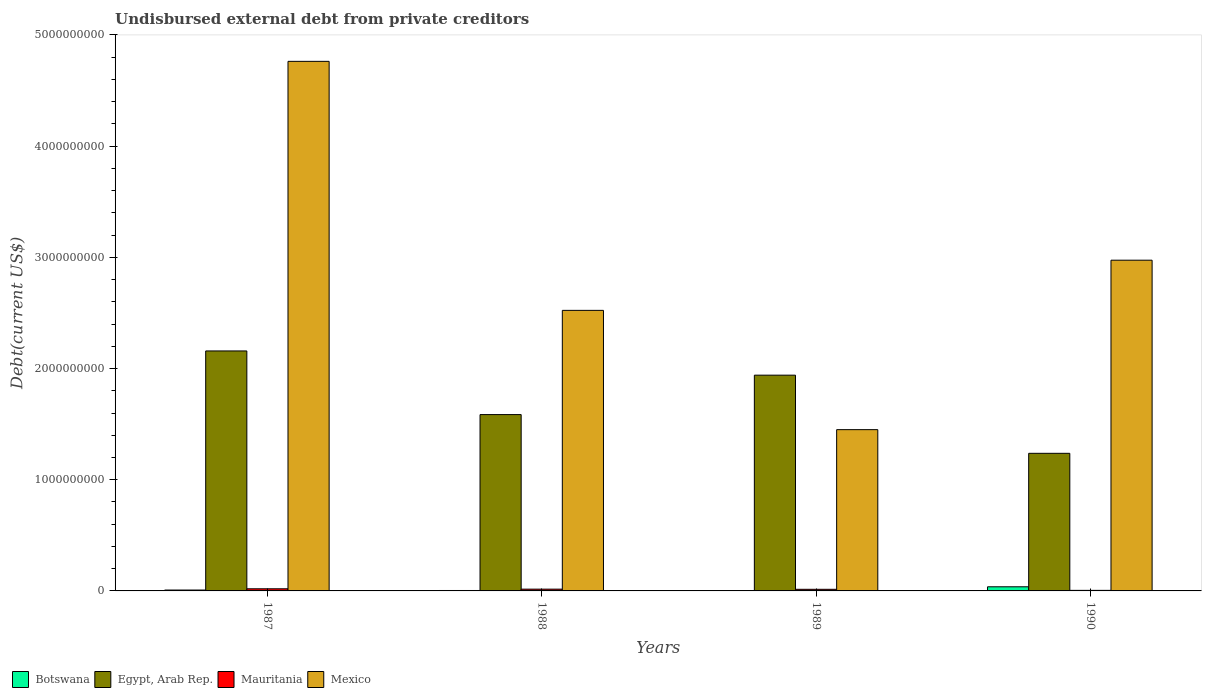How many different coloured bars are there?
Your answer should be very brief. 4. Are the number of bars per tick equal to the number of legend labels?
Your answer should be very brief. Yes. How many bars are there on the 4th tick from the left?
Your answer should be very brief. 4. How many bars are there on the 2nd tick from the right?
Your answer should be compact. 4. What is the label of the 1st group of bars from the left?
Offer a very short reply. 1987. In how many cases, is the number of bars for a given year not equal to the number of legend labels?
Provide a short and direct response. 0. What is the total debt in Mauritania in 1989?
Your response must be concise. 1.46e+07. Across all years, what is the maximum total debt in Mauritania?
Provide a short and direct response. 1.92e+07. Across all years, what is the minimum total debt in Egypt, Arab Rep.?
Provide a succinct answer. 1.24e+09. In which year was the total debt in Mauritania maximum?
Your answer should be compact. 1987. What is the total total debt in Mauritania in the graph?
Offer a terse response. 5.47e+07. What is the difference between the total debt in Botswana in 1988 and that in 1989?
Provide a short and direct response. 6.15e+05. What is the difference between the total debt in Mexico in 1987 and the total debt in Botswana in 1989?
Ensure brevity in your answer.  4.76e+09. What is the average total debt in Mexico per year?
Ensure brevity in your answer.  2.93e+09. In the year 1988, what is the difference between the total debt in Botswana and total debt in Mauritania?
Provide a short and direct response. -1.20e+07. What is the ratio of the total debt in Botswana in 1988 to that in 1990?
Offer a very short reply. 0.1. What is the difference between the highest and the second highest total debt in Mexico?
Make the answer very short. 1.79e+09. What is the difference between the highest and the lowest total debt in Botswana?
Provide a short and direct response. 3.39e+07. In how many years, is the total debt in Mauritania greater than the average total debt in Mauritania taken over all years?
Keep it short and to the point. 3. Is the sum of the total debt in Egypt, Arab Rep. in 1989 and 1990 greater than the maximum total debt in Mexico across all years?
Make the answer very short. No. Is it the case that in every year, the sum of the total debt in Mauritania and total debt in Mexico is greater than the sum of total debt in Botswana and total debt in Egypt, Arab Rep.?
Your response must be concise. Yes. What does the 3rd bar from the left in 1987 represents?
Your answer should be very brief. Mauritania. What does the 4th bar from the right in 1988 represents?
Keep it short and to the point. Botswana. Is it the case that in every year, the sum of the total debt in Botswana and total debt in Mexico is greater than the total debt in Egypt, Arab Rep.?
Offer a very short reply. No. Are all the bars in the graph horizontal?
Provide a short and direct response. No. Does the graph contain any zero values?
Your response must be concise. No. Does the graph contain grids?
Your answer should be compact. No. Where does the legend appear in the graph?
Your response must be concise. Bottom left. What is the title of the graph?
Your answer should be compact. Undisbursed external debt from private creditors. What is the label or title of the Y-axis?
Your answer should be compact. Debt(current US$). What is the Debt(current US$) in Botswana in 1987?
Make the answer very short. 7.99e+06. What is the Debt(current US$) of Egypt, Arab Rep. in 1987?
Give a very brief answer. 2.16e+09. What is the Debt(current US$) of Mauritania in 1987?
Offer a very short reply. 1.92e+07. What is the Debt(current US$) of Mexico in 1987?
Offer a very short reply. 4.76e+09. What is the Debt(current US$) in Botswana in 1988?
Provide a succinct answer. 3.90e+06. What is the Debt(current US$) in Egypt, Arab Rep. in 1988?
Provide a short and direct response. 1.59e+09. What is the Debt(current US$) of Mauritania in 1988?
Ensure brevity in your answer.  1.59e+07. What is the Debt(current US$) in Mexico in 1988?
Your response must be concise. 2.52e+09. What is the Debt(current US$) in Botswana in 1989?
Offer a terse response. 3.28e+06. What is the Debt(current US$) in Egypt, Arab Rep. in 1989?
Ensure brevity in your answer.  1.94e+09. What is the Debt(current US$) of Mauritania in 1989?
Ensure brevity in your answer.  1.46e+07. What is the Debt(current US$) of Mexico in 1989?
Ensure brevity in your answer.  1.45e+09. What is the Debt(current US$) of Botswana in 1990?
Provide a short and direct response. 3.72e+07. What is the Debt(current US$) in Egypt, Arab Rep. in 1990?
Make the answer very short. 1.24e+09. What is the Debt(current US$) of Mauritania in 1990?
Make the answer very short. 4.95e+06. What is the Debt(current US$) of Mexico in 1990?
Provide a succinct answer. 2.97e+09. Across all years, what is the maximum Debt(current US$) in Botswana?
Provide a succinct answer. 3.72e+07. Across all years, what is the maximum Debt(current US$) in Egypt, Arab Rep.?
Your response must be concise. 2.16e+09. Across all years, what is the maximum Debt(current US$) of Mauritania?
Provide a short and direct response. 1.92e+07. Across all years, what is the maximum Debt(current US$) in Mexico?
Your answer should be very brief. 4.76e+09. Across all years, what is the minimum Debt(current US$) of Botswana?
Your answer should be compact. 3.28e+06. Across all years, what is the minimum Debt(current US$) in Egypt, Arab Rep.?
Your answer should be very brief. 1.24e+09. Across all years, what is the minimum Debt(current US$) of Mauritania?
Give a very brief answer. 4.95e+06. Across all years, what is the minimum Debt(current US$) in Mexico?
Your answer should be compact. 1.45e+09. What is the total Debt(current US$) of Botswana in the graph?
Provide a succinct answer. 5.23e+07. What is the total Debt(current US$) in Egypt, Arab Rep. in the graph?
Keep it short and to the point. 6.92e+09. What is the total Debt(current US$) in Mauritania in the graph?
Offer a terse response. 5.47e+07. What is the total Debt(current US$) of Mexico in the graph?
Keep it short and to the point. 1.17e+1. What is the difference between the Debt(current US$) of Botswana in 1987 and that in 1988?
Give a very brief answer. 4.09e+06. What is the difference between the Debt(current US$) of Egypt, Arab Rep. in 1987 and that in 1988?
Make the answer very short. 5.72e+08. What is the difference between the Debt(current US$) of Mauritania in 1987 and that in 1988?
Give a very brief answer. 3.28e+06. What is the difference between the Debt(current US$) in Mexico in 1987 and that in 1988?
Offer a very short reply. 2.24e+09. What is the difference between the Debt(current US$) in Botswana in 1987 and that in 1989?
Provide a short and direct response. 4.70e+06. What is the difference between the Debt(current US$) in Egypt, Arab Rep. in 1987 and that in 1989?
Make the answer very short. 2.18e+08. What is the difference between the Debt(current US$) in Mauritania in 1987 and that in 1989?
Ensure brevity in your answer.  4.65e+06. What is the difference between the Debt(current US$) in Mexico in 1987 and that in 1989?
Your response must be concise. 3.31e+09. What is the difference between the Debt(current US$) in Botswana in 1987 and that in 1990?
Provide a short and direct response. -2.92e+07. What is the difference between the Debt(current US$) of Egypt, Arab Rep. in 1987 and that in 1990?
Provide a short and direct response. 9.21e+08. What is the difference between the Debt(current US$) in Mauritania in 1987 and that in 1990?
Provide a short and direct response. 1.43e+07. What is the difference between the Debt(current US$) of Mexico in 1987 and that in 1990?
Keep it short and to the point. 1.79e+09. What is the difference between the Debt(current US$) in Botswana in 1988 and that in 1989?
Give a very brief answer. 6.15e+05. What is the difference between the Debt(current US$) of Egypt, Arab Rep. in 1988 and that in 1989?
Ensure brevity in your answer.  -3.54e+08. What is the difference between the Debt(current US$) in Mauritania in 1988 and that in 1989?
Make the answer very short. 1.37e+06. What is the difference between the Debt(current US$) in Mexico in 1988 and that in 1989?
Make the answer very short. 1.07e+09. What is the difference between the Debt(current US$) in Botswana in 1988 and that in 1990?
Ensure brevity in your answer.  -3.33e+07. What is the difference between the Debt(current US$) of Egypt, Arab Rep. in 1988 and that in 1990?
Ensure brevity in your answer.  3.48e+08. What is the difference between the Debt(current US$) in Mauritania in 1988 and that in 1990?
Make the answer very short. 1.10e+07. What is the difference between the Debt(current US$) of Mexico in 1988 and that in 1990?
Offer a very short reply. -4.51e+08. What is the difference between the Debt(current US$) of Botswana in 1989 and that in 1990?
Your response must be concise. -3.39e+07. What is the difference between the Debt(current US$) in Egypt, Arab Rep. in 1989 and that in 1990?
Offer a terse response. 7.03e+08. What is the difference between the Debt(current US$) in Mauritania in 1989 and that in 1990?
Offer a terse response. 9.63e+06. What is the difference between the Debt(current US$) in Mexico in 1989 and that in 1990?
Offer a very short reply. -1.52e+09. What is the difference between the Debt(current US$) of Botswana in 1987 and the Debt(current US$) of Egypt, Arab Rep. in 1988?
Provide a short and direct response. -1.58e+09. What is the difference between the Debt(current US$) of Botswana in 1987 and the Debt(current US$) of Mauritania in 1988?
Keep it short and to the point. -7.96e+06. What is the difference between the Debt(current US$) in Botswana in 1987 and the Debt(current US$) in Mexico in 1988?
Your answer should be compact. -2.51e+09. What is the difference between the Debt(current US$) in Egypt, Arab Rep. in 1987 and the Debt(current US$) in Mauritania in 1988?
Provide a succinct answer. 2.14e+09. What is the difference between the Debt(current US$) of Egypt, Arab Rep. in 1987 and the Debt(current US$) of Mexico in 1988?
Make the answer very short. -3.65e+08. What is the difference between the Debt(current US$) in Mauritania in 1987 and the Debt(current US$) in Mexico in 1988?
Keep it short and to the point. -2.50e+09. What is the difference between the Debt(current US$) of Botswana in 1987 and the Debt(current US$) of Egypt, Arab Rep. in 1989?
Your answer should be compact. -1.93e+09. What is the difference between the Debt(current US$) in Botswana in 1987 and the Debt(current US$) in Mauritania in 1989?
Offer a very short reply. -6.60e+06. What is the difference between the Debt(current US$) in Botswana in 1987 and the Debt(current US$) in Mexico in 1989?
Ensure brevity in your answer.  -1.44e+09. What is the difference between the Debt(current US$) in Egypt, Arab Rep. in 1987 and the Debt(current US$) in Mauritania in 1989?
Ensure brevity in your answer.  2.14e+09. What is the difference between the Debt(current US$) of Egypt, Arab Rep. in 1987 and the Debt(current US$) of Mexico in 1989?
Provide a short and direct response. 7.08e+08. What is the difference between the Debt(current US$) of Mauritania in 1987 and the Debt(current US$) of Mexico in 1989?
Make the answer very short. -1.43e+09. What is the difference between the Debt(current US$) of Botswana in 1987 and the Debt(current US$) of Egypt, Arab Rep. in 1990?
Give a very brief answer. -1.23e+09. What is the difference between the Debt(current US$) of Botswana in 1987 and the Debt(current US$) of Mauritania in 1990?
Your answer should be compact. 3.04e+06. What is the difference between the Debt(current US$) in Botswana in 1987 and the Debt(current US$) in Mexico in 1990?
Provide a succinct answer. -2.97e+09. What is the difference between the Debt(current US$) of Egypt, Arab Rep. in 1987 and the Debt(current US$) of Mauritania in 1990?
Your response must be concise. 2.15e+09. What is the difference between the Debt(current US$) in Egypt, Arab Rep. in 1987 and the Debt(current US$) in Mexico in 1990?
Your response must be concise. -8.16e+08. What is the difference between the Debt(current US$) of Mauritania in 1987 and the Debt(current US$) of Mexico in 1990?
Offer a terse response. -2.95e+09. What is the difference between the Debt(current US$) of Botswana in 1988 and the Debt(current US$) of Egypt, Arab Rep. in 1989?
Your response must be concise. -1.94e+09. What is the difference between the Debt(current US$) in Botswana in 1988 and the Debt(current US$) in Mauritania in 1989?
Your response must be concise. -1.07e+07. What is the difference between the Debt(current US$) of Botswana in 1988 and the Debt(current US$) of Mexico in 1989?
Provide a short and direct response. -1.45e+09. What is the difference between the Debt(current US$) in Egypt, Arab Rep. in 1988 and the Debt(current US$) in Mauritania in 1989?
Ensure brevity in your answer.  1.57e+09. What is the difference between the Debt(current US$) in Egypt, Arab Rep. in 1988 and the Debt(current US$) in Mexico in 1989?
Ensure brevity in your answer.  1.35e+08. What is the difference between the Debt(current US$) in Mauritania in 1988 and the Debt(current US$) in Mexico in 1989?
Provide a short and direct response. -1.43e+09. What is the difference between the Debt(current US$) of Botswana in 1988 and the Debt(current US$) of Egypt, Arab Rep. in 1990?
Ensure brevity in your answer.  -1.23e+09. What is the difference between the Debt(current US$) in Botswana in 1988 and the Debt(current US$) in Mauritania in 1990?
Give a very brief answer. -1.05e+06. What is the difference between the Debt(current US$) in Botswana in 1988 and the Debt(current US$) in Mexico in 1990?
Keep it short and to the point. -2.97e+09. What is the difference between the Debt(current US$) of Egypt, Arab Rep. in 1988 and the Debt(current US$) of Mauritania in 1990?
Offer a terse response. 1.58e+09. What is the difference between the Debt(current US$) of Egypt, Arab Rep. in 1988 and the Debt(current US$) of Mexico in 1990?
Give a very brief answer. -1.39e+09. What is the difference between the Debt(current US$) of Mauritania in 1988 and the Debt(current US$) of Mexico in 1990?
Your answer should be very brief. -2.96e+09. What is the difference between the Debt(current US$) of Botswana in 1989 and the Debt(current US$) of Egypt, Arab Rep. in 1990?
Your response must be concise. -1.23e+09. What is the difference between the Debt(current US$) in Botswana in 1989 and the Debt(current US$) in Mauritania in 1990?
Offer a very short reply. -1.66e+06. What is the difference between the Debt(current US$) of Botswana in 1989 and the Debt(current US$) of Mexico in 1990?
Provide a short and direct response. -2.97e+09. What is the difference between the Debt(current US$) of Egypt, Arab Rep. in 1989 and the Debt(current US$) of Mauritania in 1990?
Provide a succinct answer. 1.94e+09. What is the difference between the Debt(current US$) of Egypt, Arab Rep. in 1989 and the Debt(current US$) of Mexico in 1990?
Keep it short and to the point. -1.03e+09. What is the difference between the Debt(current US$) of Mauritania in 1989 and the Debt(current US$) of Mexico in 1990?
Offer a very short reply. -2.96e+09. What is the average Debt(current US$) of Botswana per year?
Give a very brief answer. 1.31e+07. What is the average Debt(current US$) in Egypt, Arab Rep. per year?
Your response must be concise. 1.73e+09. What is the average Debt(current US$) in Mauritania per year?
Make the answer very short. 1.37e+07. What is the average Debt(current US$) in Mexico per year?
Provide a succinct answer. 2.93e+09. In the year 1987, what is the difference between the Debt(current US$) of Botswana and Debt(current US$) of Egypt, Arab Rep.?
Give a very brief answer. -2.15e+09. In the year 1987, what is the difference between the Debt(current US$) in Botswana and Debt(current US$) in Mauritania?
Offer a terse response. -1.12e+07. In the year 1987, what is the difference between the Debt(current US$) of Botswana and Debt(current US$) of Mexico?
Your response must be concise. -4.75e+09. In the year 1987, what is the difference between the Debt(current US$) of Egypt, Arab Rep. and Debt(current US$) of Mauritania?
Your answer should be very brief. 2.14e+09. In the year 1987, what is the difference between the Debt(current US$) of Egypt, Arab Rep. and Debt(current US$) of Mexico?
Keep it short and to the point. -2.60e+09. In the year 1987, what is the difference between the Debt(current US$) of Mauritania and Debt(current US$) of Mexico?
Your answer should be very brief. -4.74e+09. In the year 1988, what is the difference between the Debt(current US$) of Botswana and Debt(current US$) of Egypt, Arab Rep.?
Your response must be concise. -1.58e+09. In the year 1988, what is the difference between the Debt(current US$) of Botswana and Debt(current US$) of Mauritania?
Offer a very short reply. -1.20e+07. In the year 1988, what is the difference between the Debt(current US$) of Botswana and Debt(current US$) of Mexico?
Give a very brief answer. -2.52e+09. In the year 1988, what is the difference between the Debt(current US$) of Egypt, Arab Rep. and Debt(current US$) of Mauritania?
Keep it short and to the point. 1.57e+09. In the year 1988, what is the difference between the Debt(current US$) of Egypt, Arab Rep. and Debt(current US$) of Mexico?
Provide a succinct answer. -9.37e+08. In the year 1988, what is the difference between the Debt(current US$) in Mauritania and Debt(current US$) in Mexico?
Keep it short and to the point. -2.51e+09. In the year 1989, what is the difference between the Debt(current US$) in Botswana and Debt(current US$) in Egypt, Arab Rep.?
Your answer should be very brief. -1.94e+09. In the year 1989, what is the difference between the Debt(current US$) in Botswana and Debt(current US$) in Mauritania?
Provide a short and direct response. -1.13e+07. In the year 1989, what is the difference between the Debt(current US$) in Botswana and Debt(current US$) in Mexico?
Make the answer very short. -1.45e+09. In the year 1989, what is the difference between the Debt(current US$) in Egypt, Arab Rep. and Debt(current US$) in Mauritania?
Give a very brief answer. 1.93e+09. In the year 1989, what is the difference between the Debt(current US$) of Egypt, Arab Rep. and Debt(current US$) of Mexico?
Offer a very short reply. 4.90e+08. In the year 1989, what is the difference between the Debt(current US$) in Mauritania and Debt(current US$) in Mexico?
Give a very brief answer. -1.44e+09. In the year 1990, what is the difference between the Debt(current US$) in Botswana and Debt(current US$) in Egypt, Arab Rep.?
Offer a very short reply. -1.20e+09. In the year 1990, what is the difference between the Debt(current US$) of Botswana and Debt(current US$) of Mauritania?
Your response must be concise. 3.22e+07. In the year 1990, what is the difference between the Debt(current US$) in Botswana and Debt(current US$) in Mexico?
Your response must be concise. -2.94e+09. In the year 1990, what is the difference between the Debt(current US$) of Egypt, Arab Rep. and Debt(current US$) of Mauritania?
Give a very brief answer. 1.23e+09. In the year 1990, what is the difference between the Debt(current US$) in Egypt, Arab Rep. and Debt(current US$) in Mexico?
Your answer should be very brief. -1.74e+09. In the year 1990, what is the difference between the Debt(current US$) of Mauritania and Debt(current US$) of Mexico?
Ensure brevity in your answer.  -2.97e+09. What is the ratio of the Debt(current US$) of Botswana in 1987 to that in 1988?
Your answer should be very brief. 2.05. What is the ratio of the Debt(current US$) of Egypt, Arab Rep. in 1987 to that in 1988?
Your answer should be compact. 1.36. What is the ratio of the Debt(current US$) in Mauritania in 1987 to that in 1988?
Provide a short and direct response. 1.21. What is the ratio of the Debt(current US$) in Mexico in 1987 to that in 1988?
Provide a succinct answer. 1.89. What is the ratio of the Debt(current US$) in Botswana in 1987 to that in 1989?
Offer a terse response. 2.43. What is the ratio of the Debt(current US$) of Egypt, Arab Rep. in 1987 to that in 1989?
Keep it short and to the point. 1.11. What is the ratio of the Debt(current US$) of Mauritania in 1987 to that in 1989?
Give a very brief answer. 1.32. What is the ratio of the Debt(current US$) of Mexico in 1987 to that in 1989?
Provide a short and direct response. 3.28. What is the ratio of the Debt(current US$) of Botswana in 1987 to that in 1990?
Your response must be concise. 0.21. What is the ratio of the Debt(current US$) in Egypt, Arab Rep. in 1987 to that in 1990?
Keep it short and to the point. 1.74. What is the ratio of the Debt(current US$) in Mauritania in 1987 to that in 1990?
Offer a very short reply. 3.89. What is the ratio of the Debt(current US$) in Mexico in 1987 to that in 1990?
Give a very brief answer. 1.6. What is the ratio of the Debt(current US$) of Botswana in 1988 to that in 1989?
Your answer should be very brief. 1.19. What is the ratio of the Debt(current US$) of Egypt, Arab Rep. in 1988 to that in 1989?
Keep it short and to the point. 0.82. What is the ratio of the Debt(current US$) of Mauritania in 1988 to that in 1989?
Keep it short and to the point. 1.09. What is the ratio of the Debt(current US$) of Mexico in 1988 to that in 1989?
Offer a terse response. 1.74. What is the ratio of the Debt(current US$) in Botswana in 1988 to that in 1990?
Your answer should be compact. 0.1. What is the ratio of the Debt(current US$) of Egypt, Arab Rep. in 1988 to that in 1990?
Offer a very short reply. 1.28. What is the ratio of the Debt(current US$) in Mauritania in 1988 to that in 1990?
Ensure brevity in your answer.  3.22. What is the ratio of the Debt(current US$) of Mexico in 1988 to that in 1990?
Your response must be concise. 0.85. What is the ratio of the Debt(current US$) of Botswana in 1989 to that in 1990?
Your answer should be very brief. 0.09. What is the ratio of the Debt(current US$) in Egypt, Arab Rep. in 1989 to that in 1990?
Your answer should be compact. 1.57. What is the ratio of the Debt(current US$) in Mauritania in 1989 to that in 1990?
Your response must be concise. 2.95. What is the ratio of the Debt(current US$) of Mexico in 1989 to that in 1990?
Make the answer very short. 0.49. What is the difference between the highest and the second highest Debt(current US$) of Botswana?
Ensure brevity in your answer.  2.92e+07. What is the difference between the highest and the second highest Debt(current US$) in Egypt, Arab Rep.?
Offer a terse response. 2.18e+08. What is the difference between the highest and the second highest Debt(current US$) of Mauritania?
Your answer should be very brief. 3.28e+06. What is the difference between the highest and the second highest Debt(current US$) of Mexico?
Give a very brief answer. 1.79e+09. What is the difference between the highest and the lowest Debt(current US$) in Botswana?
Your answer should be compact. 3.39e+07. What is the difference between the highest and the lowest Debt(current US$) of Egypt, Arab Rep.?
Offer a terse response. 9.21e+08. What is the difference between the highest and the lowest Debt(current US$) in Mauritania?
Your response must be concise. 1.43e+07. What is the difference between the highest and the lowest Debt(current US$) of Mexico?
Give a very brief answer. 3.31e+09. 